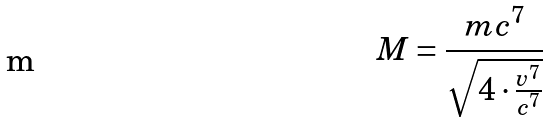Convert formula to latex. <formula><loc_0><loc_0><loc_500><loc_500>M = \frac { m c ^ { 7 } } { \sqrt { 4 \cdot \frac { v ^ { 7 } } { c ^ { 7 } } } }</formula> 